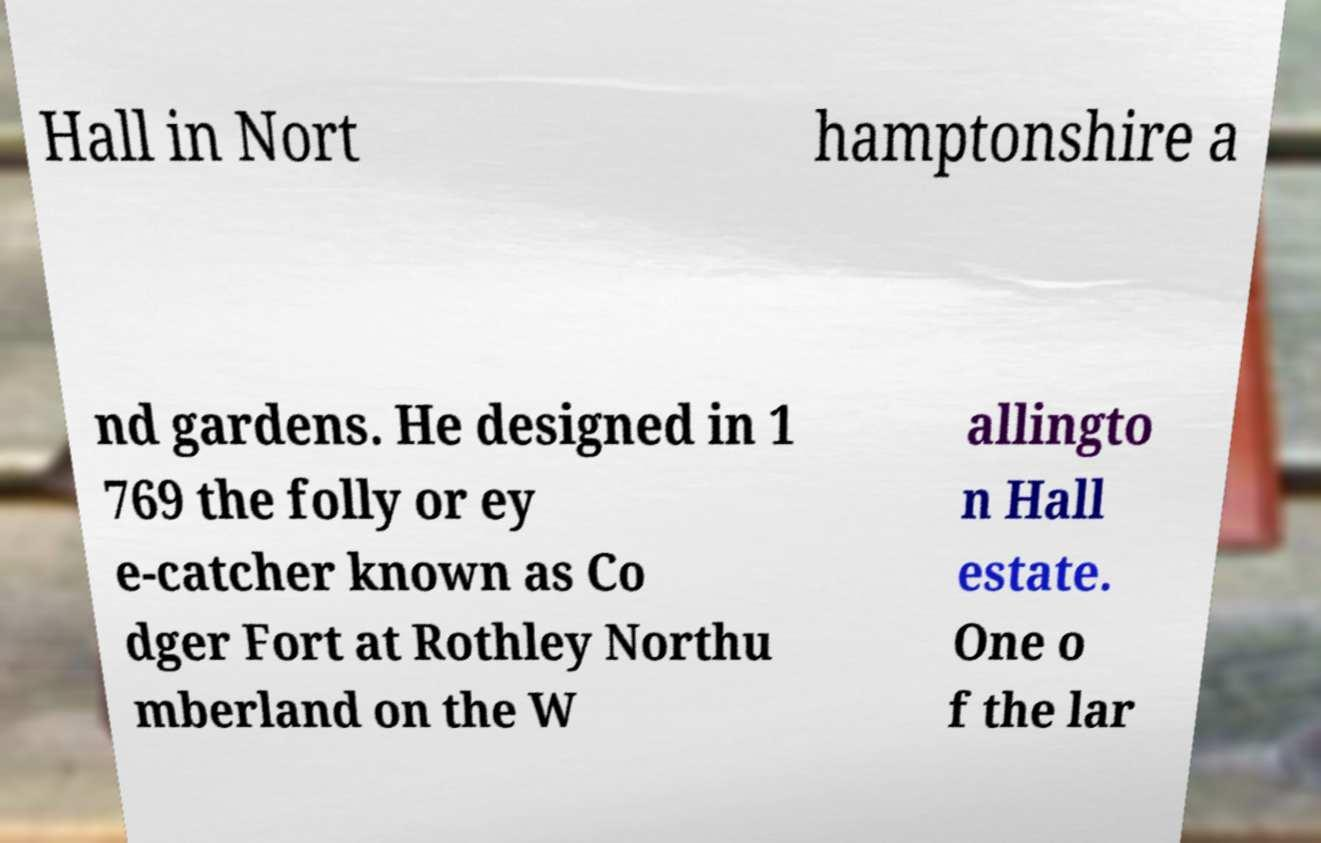I need the written content from this picture converted into text. Can you do that? Hall in Nort hamptonshire a nd gardens. He designed in 1 769 the folly or ey e-catcher known as Co dger Fort at Rothley Northu mberland on the W allingto n Hall estate. One o f the lar 